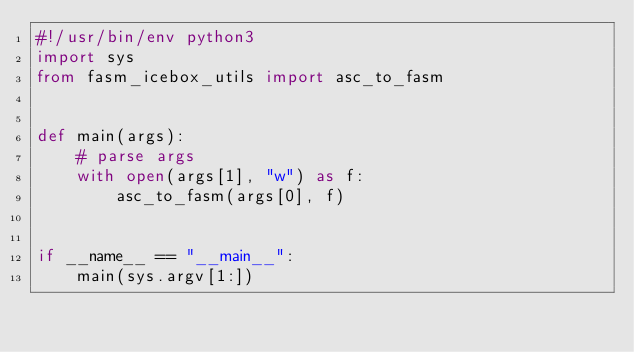Convert code to text. <code><loc_0><loc_0><loc_500><loc_500><_Python_>#!/usr/bin/env python3
import sys
from fasm_icebox_utils import asc_to_fasm


def main(args):
    # parse args
    with open(args[1], "w") as f:
        asc_to_fasm(args[0], f)


if __name__ == "__main__":
    main(sys.argv[1:])
</code> 